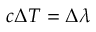<formula> <loc_0><loc_0><loc_500><loc_500>c { \Delta } T = \Delta \lambda</formula> 